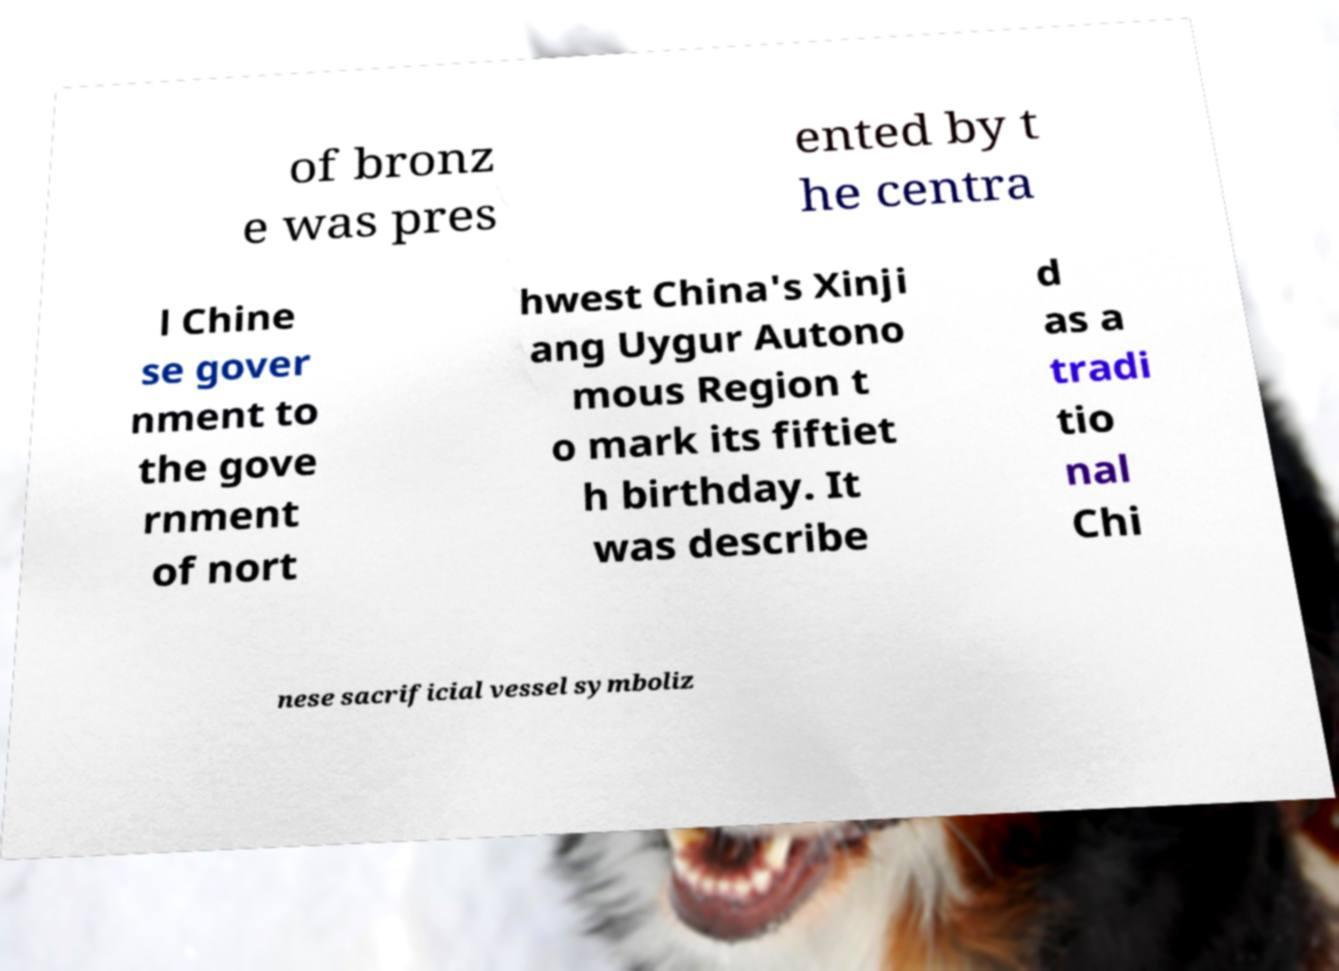Could you assist in decoding the text presented in this image and type it out clearly? of bronz e was pres ented by t he centra l Chine se gover nment to the gove rnment of nort hwest China's Xinji ang Uygur Autono mous Region t o mark its fiftiet h birthday. It was describe d as a tradi tio nal Chi nese sacrificial vessel symboliz 